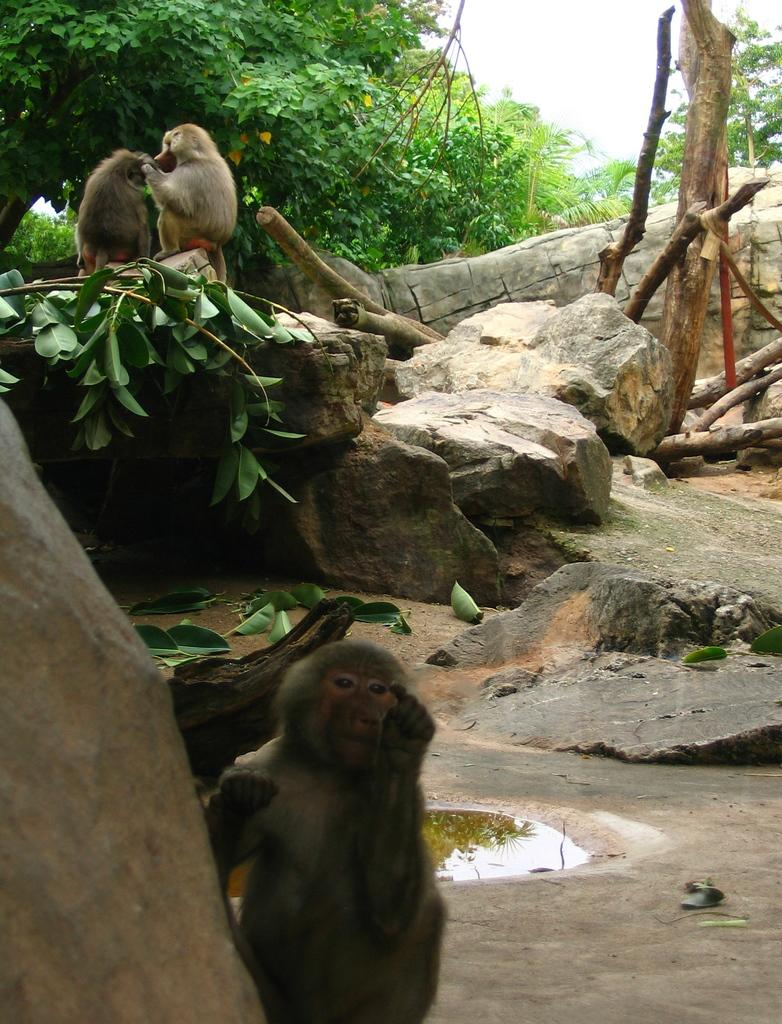What type of animals can be seen in the image? There are monkeys in the image. What natural elements are present in the image? There are rocks, branches of a plant, leaves on the ground, water, a group of trees, and wooden logs visible in the image. What part of the natural environment is visible in the image? The sky is visible in the image. Can you see any fairies flying around the trees in the image? There are no fairies present in the image; it features monkeys, rocks, branches, leaves, water, trees, wooden logs, and the sky. 